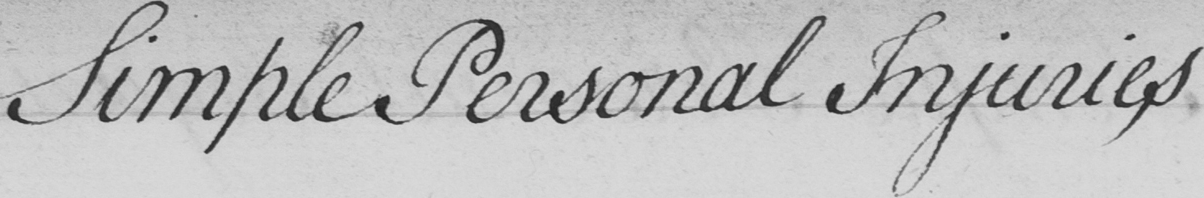Can you read and transcribe this handwriting? Simple Personal Injuries 